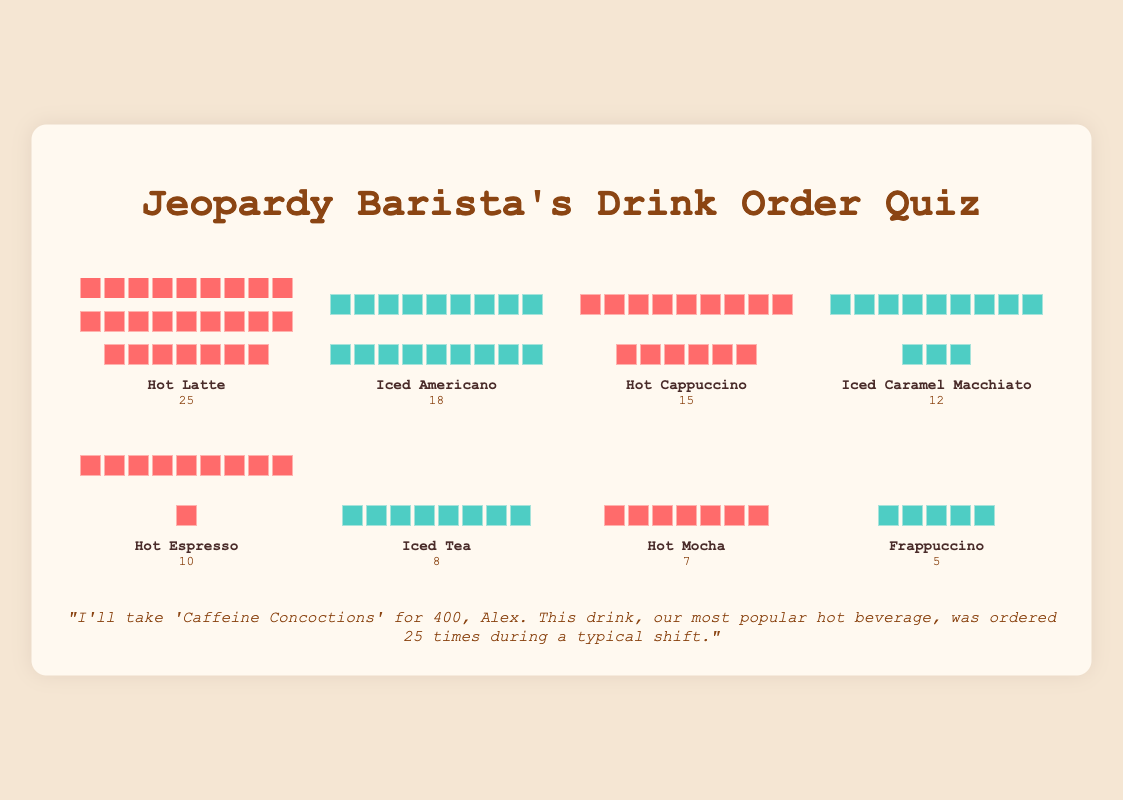Which drink type has the highest number of orders? By observing the cup icons for each drink type, the Hot Latte has the most icons, indicating it has the highest number of orders with 25.
Answer: Hot Latte What's the total number of cold drink orders? Sum the counts of all drinks labeled with cold cup icons: Iced Americano (18), Iced Caramel Macchiato (12), Iced Tea (8), and Frappuccino (5). The total is 18 + 12 + 8 + 5 = 43.
Answer: 43 How many more Hot Lattes were ordered compared to Hot Mochas? Hot Latte has 25 orders and Hot Mocha has 7 orders. The difference is 25 - 7 = 18.
Answer: 18 Which cold drink had the fewest orders? By comparing the number of icons for each cold drink, Frappuccino has the fewest with 5 orders.
Answer: Frappuccino What's the total number of hot drink orders? Sum the counts of all drinks labeled with hot cup icons: Hot Latte (25), Hot Cappuccino (15), Hot Espresso (10), and Hot Mocha (7). The total is 25 + 15 + 10 + 7 = 57.
Answer: 57 What percentage of the total orders were Hot Lattes? First, find the total number of orders by summing all counts: 25 + 18 + 15 + 12 + 10 + 8 + 7 + 5 = 100. Then, calculate the percentage of Hot Lattes: (25/100) * 100% = 25%.
Answer: 25% Which drink is ordered exactly half the amount of Hot Lattes? Hot Latte has 25 orders, half of which is 12.5. The closest drink with a count near 12.5 is Iced Caramel Macchiato with 12 orders.
Answer: Iced Caramel Macchiato How do the orders of Hot Espresso compare to those of Hot Mocha and Frappuccino combined? Hot Espresso has 10 orders. Hot Mocha and Frappuccino combined have 7 + 5 = 12 orders. 10 is less than 12.
Answer: less What's the average count of orders for cold drinks? Sum the counts for cold drinks and divide by the number of cold drinks: (18 + 12 + 8 + 5) / 4 = 43 / 4 = 10.75
Answer: 10.75 